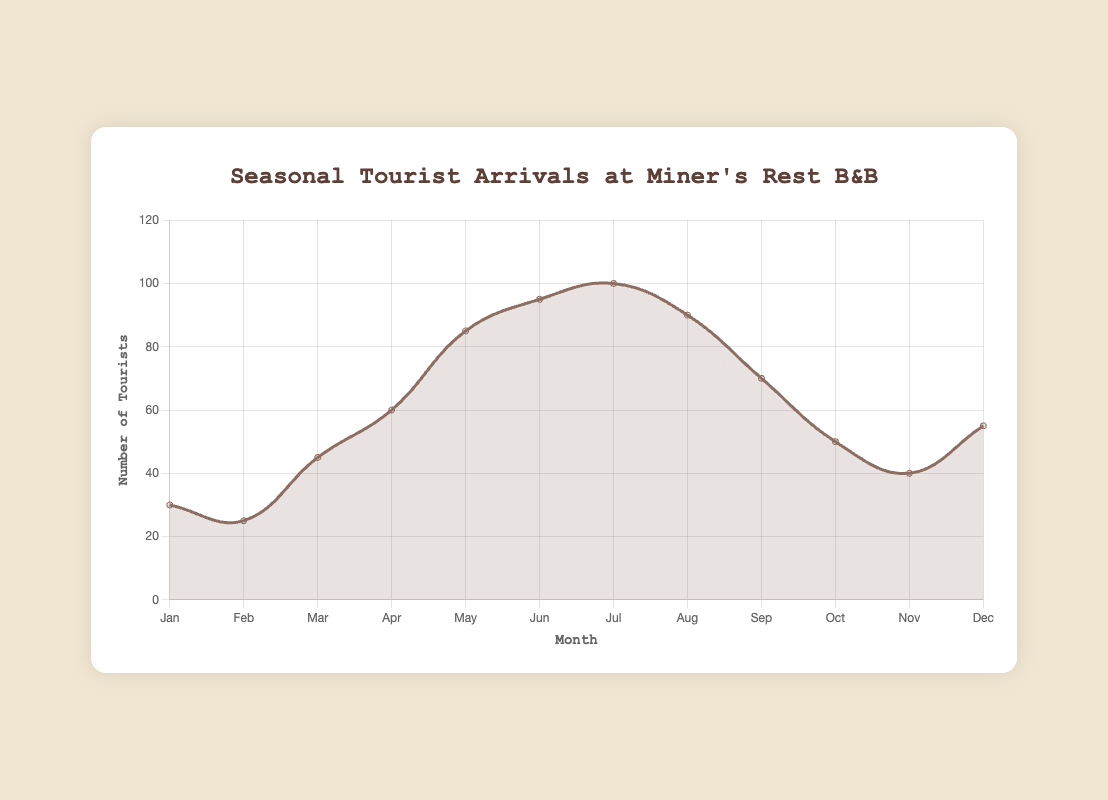What month has the highest number of tourist arrivals? According to the figure, July has the highest number of tourist arrivals, which is 100. This can be observed by identifying the tallest point in the plot.
Answer: July What is the difference in tourist arrivals between peak and off-peak periods in April and October? In April, during the peak period, there are 60 tourist arrivals. In October, during the off-peak period, there are 50 tourist arrivals. The difference is calculated as 60 - 50 = 10.
Answer: 10 During which period, peak or off-peak, is the range of tourist arrivals greater? The range is calculated as the difference between the highest and lowest values. For the peak period (April to September), the range is 100 (highest in July) - 60 (lowest in April) = 40. For the off-peak period (October to March), the range is 55 (highest in December) - 25 (lowest in February) = 30. Therefore, the peak period has a greater range.
Answer: Peak How many tourists arrived at the bed and breakfast during the peak period (April to September)? To find the total number of tourists during the peak period, sum the values for each month from April to September: 60 + 85 + 95 + 100 + 90 + 70 = 500.
Answer: 500 What is the average number of tourist arrivals during the off-peak period? The off-peak period includes the months of January, February, March, October, November, and December. The average is calculated by summing the arrivals and dividing by the number of months. (30 + 25 + 45 + 50 + 40 + 55) / 6 = 245 / 6 ≈ 40.83.
Answer: ~40.83 In which month do tourist arrivals begin to decline after reaching their peak? Observing the plot, after reaching the peak in July (100), the tourist arrivals begin to decline in August (90).
Answer: August How does the number of tourist arrivals change from February to March? From February (25) to March (45), the number of tourist arrivals increases. The difference is calculated as 45 - 25 = 20.
Answer: Increases by 20 Which month experiences the smallest number of tourist arrivals, and what is that number? The month with the smallest number of tourist arrivals is February, with 25 tourists.
Answer: February What is the ratio of tourist arrivals in June to those in December? In June, there are 95 tourist arrivals, and in December, there are 55. The ratio is calculated as 95 / 55 ≈ 1.73.
Answer: ~1.73 